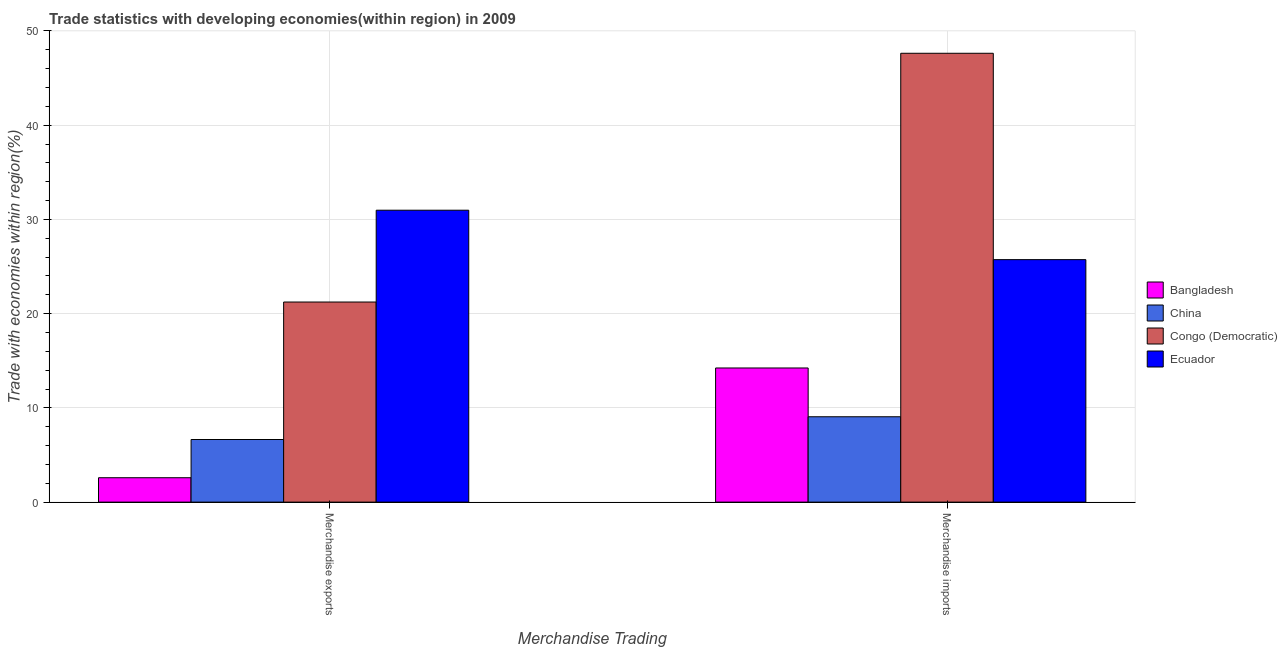How many different coloured bars are there?
Make the answer very short. 4. Are the number of bars on each tick of the X-axis equal?
Provide a succinct answer. Yes. How many bars are there on the 2nd tick from the left?
Keep it short and to the point. 4. What is the merchandise exports in Ecuador?
Ensure brevity in your answer.  30.98. Across all countries, what is the maximum merchandise exports?
Provide a short and direct response. 30.98. Across all countries, what is the minimum merchandise imports?
Ensure brevity in your answer.  9.06. In which country was the merchandise exports maximum?
Provide a succinct answer. Ecuador. What is the total merchandise exports in the graph?
Offer a very short reply. 61.44. What is the difference between the merchandise imports in Bangladesh and that in China?
Your answer should be very brief. 5.18. What is the difference between the merchandise imports in Congo (Democratic) and the merchandise exports in Bangladesh?
Offer a very short reply. 45.04. What is the average merchandise exports per country?
Your answer should be compact. 15.36. What is the difference between the merchandise imports and merchandise exports in Ecuador?
Ensure brevity in your answer.  -5.25. In how many countries, is the merchandise exports greater than 20 %?
Provide a succinct answer. 2. What is the ratio of the merchandise imports in Congo (Democratic) to that in China?
Offer a very short reply. 5.26. In how many countries, is the merchandise imports greater than the average merchandise imports taken over all countries?
Make the answer very short. 2. What does the 3rd bar from the left in Merchandise exports represents?
Your answer should be very brief. Congo (Democratic). What does the 3rd bar from the right in Merchandise exports represents?
Offer a very short reply. China. How many bars are there?
Keep it short and to the point. 8. Are all the bars in the graph horizontal?
Give a very brief answer. No. What is the difference between two consecutive major ticks on the Y-axis?
Your answer should be compact. 10. Are the values on the major ticks of Y-axis written in scientific E-notation?
Ensure brevity in your answer.  No. Does the graph contain any zero values?
Give a very brief answer. No. How are the legend labels stacked?
Give a very brief answer. Vertical. What is the title of the graph?
Your answer should be very brief. Trade statistics with developing economies(within region) in 2009. What is the label or title of the X-axis?
Offer a very short reply. Merchandise Trading. What is the label or title of the Y-axis?
Your answer should be very brief. Trade with economies within region(%). What is the Trade with economies within region(%) of Bangladesh in Merchandise exports?
Make the answer very short. 2.59. What is the Trade with economies within region(%) in China in Merchandise exports?
Give a very brief answer. 6.64. What is the Trade with economies within region(%) of Congo (Democratic) in Merchandise exports?
Provide a succinct answer. 21.23. What is the Trade with economies within region(%) in Ecuador in Merchandise exports?
Make the answer very short. 30.98. What is the Trade with economies within region(%) of Bangladesh in Merchandise imports?
Ensure brevity in your answer.  14.23. What is the Trade with economies within region(%) in China in Merchandise imports?
Give a very brief answer. 9.06. What is the Trade with economies within region(%) in Congo (Democratic) in Merchandise imports?
Your response must be concise. 47.63. What is the Trade with economies within region(%) of Ecuador in Merchandise imports?
Provide a succinct answer. 25.73. Across all Merchandise Trading, what is the maximum Trade with economies within region(%) in Bangladesh?
Provide a short and direct response. 14.23. Across all Merchandise Trading, what is the maximum Trade with economies within region(%) in China?
Keep it short and to the point. 9.06. Across all Merchandise Trading, what is the maximum Trade with economies within region(%) in Congo (Democratic)?
Your answer should be very brief. 47.63. Across all Merchandise Trading, what is the maximum Trade with economies within region(%) in Ecuador?
Offer a terse response. 30.98. Across all Merchandise Trading, what is the minimum Trade with economies within region(%) of Bangladesh?
Provide a short and direct response. 2.59. Across all Merchandise Trading, what is the minimum Trade with economies within region(%) of China?
Your answer should be compact. 6.64. Across all Merchandise Trading, what is the minimum Trade with economies within region(%) of Congo (Democratic)?
Keep it short and to the point. 21.23. Across all Merchandise Trading, what is the minimum Trade with economies within region(%) in Ecuador?
Offer a terse response. 25.73. What is the total Trade with economies within region(%) in Bangladesh in the graph?
Your response must be concise. 16.82. What is the total Trade with economies within region(%) in China in the graph?
Provide a short and direct response. 15.7. What is the total Trade with economies within region(%) in Congo (Democratic) in the graph?
Your answer should be compact. 68.86. What is the total Trade with economies within region(%) in Ecuador in the graph?
Provide a succinct answer. 56.71. What is the difference between the Trade with economies within region(%) in Bangladesh in Merchandise exports and that in Merchandise imports?
Provide a short and direct response. -11.65. What is the difference between the Trade with economies within region(%) of China in Merchandise exports and that in Merchandise imports?
Give a very brief answer. -2.41. What is the difference between the Trade with economies within region(%) in Congo (Democratic) in Merchandise exports and that in Merchandise imports?
Provide a succinct answer. -26.4. What is the difference between the Trade with economies within region(%) in Ecuador in Merchandise exports and that in Merchandise imports?
Give a very brief answer. 5.25. What is the difference between the Trade with economies within region(%) in Bangladesh in Merchandise exports and the Trade with economies within region(%) in China in Merchandise imports?
Ensure brevity in your answer.  -6.47. What is the difference between the Trade with economies within region(%) of Bangladesh in Merchandise exports and the Trade with economies within region(%) of Congo (Democratic) in Merchandise imports?
Keep it short and to the point. -45.04. What is the difference between the Trade with economies within region(%) in Bangladesh in Merchandise exports and the Trade with economies within region(%) in Ecuador in Merchandise imports?
Keep it short and to the point. -23.14. What is the difference between the Trade with economies within region(%) of China in Merchandise exports and the Trade with economies within region(%) of Congo (Democratic) in Merchandise imports?
Your answer should be very brief. -40.98. What is the difference between the Trade with economies within region(%) in China in Merchandise exports and the Trade with economies within region(%) in Ecuador in Merchandise imports?
Ensure brevity in your answer.  -19.09. What is the difference between the Trade with economies within region(%) of Congo (Democratic) in Merchandise exports and the Trade with economies within region(%) of Ecuador in Merchandise imports?
Give a very brief answer. -4.5. What is the average Trade with economies within region(%) in Bangladesh per Merchandise Trading?
Your answer should be compact. 8.41. What is the average Trade with economies within region(%) in China per Merchandise Trading?
Offer a very short reply. 7.85. What is the average Trade with economies within region(%) in Congo (Democratic) per Merchandise Trading?
Offer a very short reply. 34.43. What is the average Trade with economies within region(%) of Ecuador per Merchandise Trading?
Ensure brevity in your answer.  28.35. What is the difference between the Trade with economies within region(%) in Bangladesh and Trade with economies within region(%) in China in Merchandise exports?
Give a very brief answer. -4.06. What is the difference between the Trade with economies within region(%) in Bangladesh and Trade with economies within region(%) in Congo (Democratic) in Merchandise exports?
Offer a terse response. -18.64. What is the difference between the Trade with economies within region(%) in Bangladesh and Trade with economies within region(%) in Ecuador in Merchandise exports?
Your answer should be compact. -28.39. What is the difference between the Trade with economies within region(%) of China and Trade with economies within region(%) of Congo (Democratic) in Merchandise exports?
Your answer should be compact. -14.59. What is the difference between the Trade with economies within region(%) in China and Trade with economies within region(%) in Ecuador in Merchandise exports?
Ensure brevity in your answer.  -24.33. What is the difference between the Trade with economies within region(%) of Congo (Democratic) and Trade with economies within region(%) of Ecuador in Merchandise exports?
Provide a short and direct response. -9.74. What is the difference between the Trade with economies within region(%) in Bangladesh and Trade with economies within region(%) in China in Merchandise imports?
Keep it short and to the point. 5.18. What is the difference between the Trade with economies within region(%) in Bangladesh and Trade with economies within region(%) in Congo (Democratic) in Merchandise imports?
Offer a terse response. -33.39. What is the difference between the Trade with economies within region(%) of Bangladesh and Trade with economies within region(%) of Ecuador in Merchandise imports?
Ensure brevity in your answer.  -11.5. What is the difference between the Trade with economies within region(%) in China and Trade with economies within region(%) in Congo (Democratic) in Merchandise imports?
Offer a terse response. -38.57. What is the difference between the Trade with economies within region(%) in China and Trade with economies within region(%) in Ecuador in Merchandise imports?
Make the answer very short. -16.67. What is the difference between the Trade with economies within region(%) in Congo (Democratic) and Trade with economies within region(%) in Ecuador in Merchandise imports?
Ensure brevity in your answer.  21.9. What is the ratio of the Trade with economies within region(%) in Bangladesh in Merchandise exports to that in Merchandise imports?
Offer a very short reply. 0.18. What is the ratio of the Trade with economies within region(%) of China in Merchandise exports to that in Merchandise imports?
Make the answer very short. 0.73. What is the ratio of the Trade with economies within region(%) in Congo (Democratic) in Merchandise exports to that in Merchandise imports?
Give a very brief answer. 0.45. What is the ratio of the Trade with economies within region(%) of Ecuador in Merchandise exports to that in Merchandise imports?
Provide a succinct answer. 1.2. What is the difference between the highest and the second highest Trade with economies within region(%) of Bangladesh?
Offer a terse response. 11.65. What is the difference between the highest and the second highest Trade with economies within region(%) of China?
Your response must be concise. 2.41. What is the difference between the highest and the second highest Trade with economies within region(%) of Congo (Democratic)?
Make the answer very short. 26.4. What is the difference between the highest and the second highest Trade with economies within region(%) in Ecuador?
Provide a succinct answer. 5.25. What is the difference between the highest and the lowest Trade with economies within region(%) of Bangladesh?
Make the answer very short. 11.65. What is the difference between the highest and the lowest Trade with economies within region(%) of China?
Ensure brevity in your answer.  2.41. What is the difference between the highest and the lowest Trade with economies within region(%) in Congo (Democratic)?
Offer a terse response. 26.4. What is the difference between the highest and the lowest Trade with economies within region(%) of Ecuador?
Your response must be concise. 5.25. 